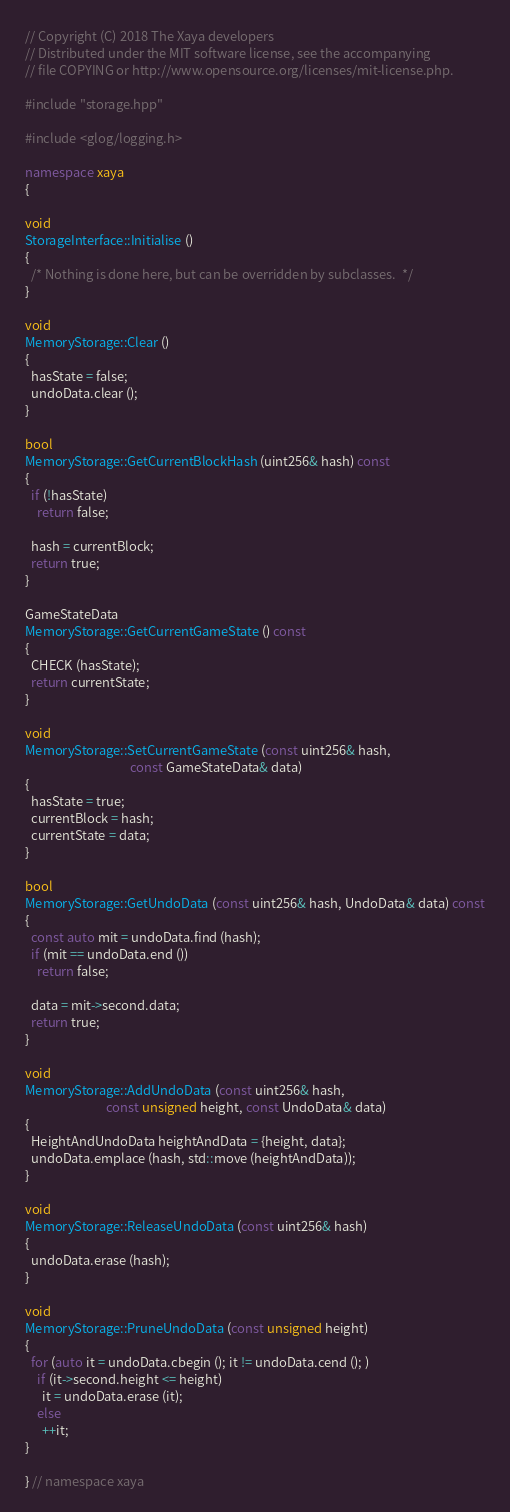<code> <loc_0><loc_0><loc_500><loc_500><_C++_>// Copyright (C) 2018 The Xaya developers
// Distributed under the MIT software license, see the accompanying
// file COPYING or http://www.opensource.org/licenses/mit-license.php.

#include "storage.hpp"

#include <glog/logging.h>

namespace xaya
{

void
StorageInterface::Initialise ()
{
  /* Nothing is done here, but can be overridden by subclasses.  */
}

void
MemoryStorage::Clear ()
{
  hasState = false;
  undoData.clear ();
}

bool
MemoryStorage::GetCurrentBlockHash (uint256& hash) const
{
  if (!hasState)
    return false;

  hash = currentBlock;
  return true;
}

GameStateData
MemoryStorage::GetCurrentGameState () const
{
  CHECK (hasState);
  return currentState;
}

void
MemoryStorage::SetCurrentGameState (const uint256& hash,
                                    const GameStateData& data)
{
  hasState = true;
  currentBlock = hash;
  currentState = data;
}

bool
MemoryStorage::GetUndoData (const uint256& hash, UndoData& data) const
{
  const auto mit = undoData.find (hash);
  if (mit == undoData.end ())
    return false;

  data = mit->second.data;
  return true;
}

void
MemoryStorage::AddUndoData (const uint256& hash,
                            const unsigned height, const UndoData& data)
{
  HeightAndUndoData heightAndData = {height, data};
  undoData.emplace (hash, std::move (heightAndData));
}

void
MemoryStorage::ReleaseUndoData (const uint256& hash)
{
  undoData.erase (hash);
}

void
MemoryStorage::PruneUndoData (const unsigned height)
{
  for (auto it = undoData.cbegin (); it != undoData.cend (); )
    if (it->second.height <= height)
      it = undoData.erase (it);
    else
      ++it;
}

} // namespace xaya
</code> 